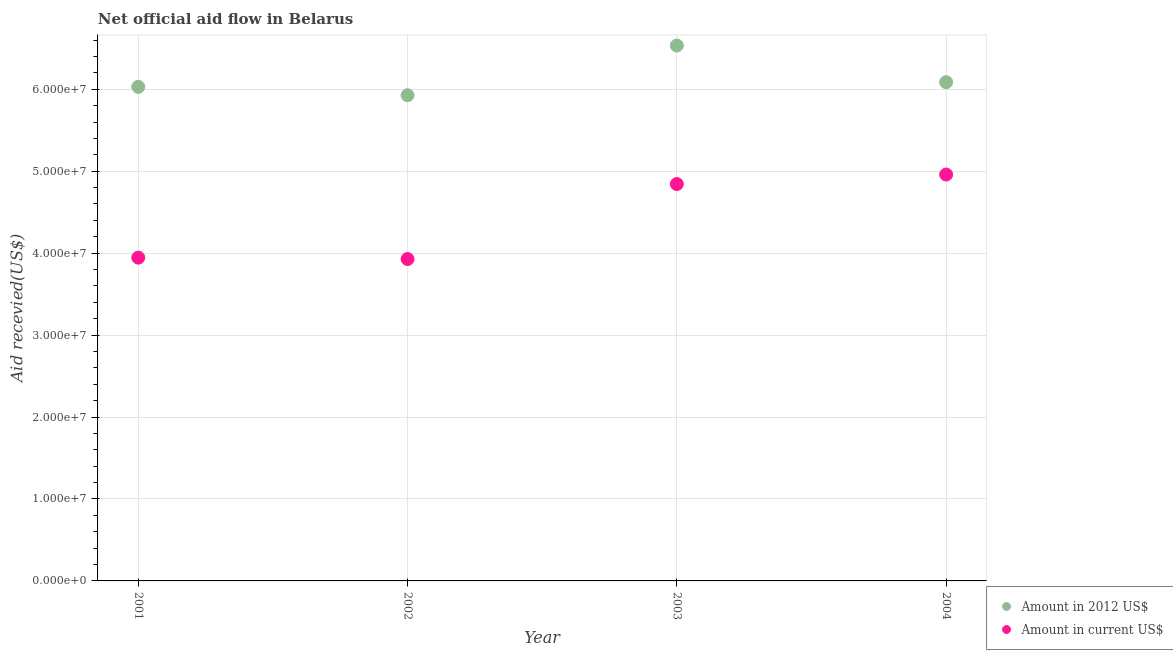Is the number of dotlines equal to the number of legend labels?
Offer a terse response. Yes. What is the amount of aid received(expressed in 2012 us$) in 2001?
Provide a succinct answer. 6.03e+07. Across all years, what is the maximum amount of aid received(expressed in us$)?
Make the answer very short. 4.96e+07. Across all years, what is the minimum amount of aid received(expressed in 2012 us$)?
Keep it short and to the point. 5.93e+07. In which year was the amount of aid received(expressed in 2012 us$) minimum?
Ensure brevity in your answer.  2002. What is the total amount of aid received(expressed in 2012 us$) in the graph?
Make the answer very short. 2.46e+08. What is the difference between the amount of aid received(expressed in 2012 us$) in 2001 and that in 2004?
Ensure brevity in your answer.  -5.70e+05. What is the difference between the amount of aid received(expressed in 2012 us$) in 2003 and the amount of aid received(expressed in us$) in 2004?
Keep it short and to the point. 1.57e+07. What is the average amount of aid received(expressed in us$) per year?
Your response must be concise. 4.42e+07. In the year 2001, what is the difference between the amount of aid received(expressed in us$) and amount of aid received(expressed in 2012 us$)?
Offer a terse response. -2.08e+07. What is the ratio of the amount of aid received(expressed in us$) in 2001 to that in 2002?
Offer a very short reply. 1. What is the difference between the highest and the second highest amount of aid received(expressed in us$)?
Give a very brief answer. 1.16e+06. What is the difference between the highest and the lowest amount of aid received(expressed in 2012 us$)?
Ensure brevity in your answer.  6.06e+06. In how many years, is the amount of aid received(expressed in us$) greater than the average amount of aid received(expressed in us$) taken over all years?
Offer a terse response. 2. Does the amount of aid received(expressed in us$) monotonically increase over the years?
Ensure brevity in your answer.  No. Is the amount of aid received(expressed in us$) strictly greater than the amount of aid received(expressed in 2012 us$) over the years?
Provide a short and direct response. No. Is the amount of aid received(expressed in 2012 us$) strictly less than the amount of aid received(expressed in us$) over the years?
Your answer should be very brief. No. How many years are there in the graph?
Offer a very short reply. 4. What is the difference between two consecutive major ticks on the Y-axis?
Offer a terse response. 1.00e+07. Are the values on the major ticks of Y-axis written in scientific E-notation?
Give a very brief answer. Yes. What is the title of the graph?
Your answer should be compact. Net official aid flow in Belarus. What is the label or title of the Y-axis?
Make the answer very short. Aid recevied(US$). What is the Aid recevied(US$) in Amount in 2012 US$ in 2001?
Provide a succinct answer. 6.03e+07. What is the Aid recevied(US$) in Amount in current US$ in 2001?
Provide a short and direct response. 3.94e+07. What is the Aid recevied(US$) in Amount in 2012 US$ in 2002?
Keep it short and to the point. 5.93e+07. What is the Aid recevied(US$) of Amount in current US$ in 2002?
Offer a very short reply. 3.93e+07. What is the Aid recevied(US$) in Amount in 2012 US$ in 2003?
Offer a very short reply. 6.53e+07. What is the Aid recevied(US$) in Amount in current US$ in 2003?
Offer a terse response. 4.84e+07. What is the Aid recevied(US$) of Amount in 2012 US$ in 2004?
Make the answer very short. 6.09e+07. What is the Aid recevied(US$) in Amount in current US$ in 2004?
Offer a very short reply. 4.96e+07. Across all years, what is the maximum Aid recevied(US$) in Amount in 2012 US$?
Provide a short and direct response. 6.53e+07. Across all years, what is the maximum Aid recevied(US$) of Amount in current US$?
Your answer should be compact. 4.96e+07. Across all years, what is the minimum Aid recevied(US$) in Amount in 2012 US$?
Provide a short and direct response. 5.93e+07. Across all years, what is the minimum Aid recevied(US$) of Amount in current US$?
Provide a short and direct response. 3.93e+07. What is the total Aid recevied(US$) of Amount in 2012 US$ in the graph?
Offer a very short reply. 2.46e+08. What is the total Aid recevied(US$) in Amount in current US$ in the graph?
Provide a succinct answer. 1.77e+08. What is the difference between the Aid recevied(US$) of Amount in 2012 US$ in 2001 and that in 2002?
Offer a terse response. 1.02e+06. What is the difference between the Aid recevied(US$) in Amount in current US$ in 2001 and that in 2002?
Ensure brevity in your answer.  1.70e+05. What is the difference between the Aid recevied(US$) of Amount in 2012 US$ in 2001 and that in 2003?
Ensure brevity in your answer.  -5.04e+06. What is the difference between the Aid recevied(US$) of Amount in current US$ in 2001 and that in 2003?
Keep it short and to the point. -8.98e+06. What is the difference between the Aid recevied(US$) in Amount in 2012 US$ in 2001 and that in 2004?
Your answer should be compact. -5.70e+05. What is the difference between the Aid recevied(US$) of Amount in current US$ in 2001 and that in 2004?
Give a very brief answer. -1.01e+07. What is the difference between the Aid recevied(US$) in Amount in 2012 US$ in 2002 and that in 2003?
Give a very brief answer. -6.06e+06. What is the difference between the Aid recevied(US$) in Amount in current US$ in 2002 and that in 2003?
Your response must be concise. -9.15e+06. What is the difference between the Aid recevied(US$) of Amount in 2012 US$ in 2002 and that in 2004?
Offer a very short reply. -1.59e+06. What is the difference between the Aid recevied(US$) in Amount in current US$ in 2002 and that in 2004?
Your answer should be compact. -1.03e+07. What is the difference between the Aid recevied(US$) in Amount in 2012 US$ in 2003 and that in 2004?
Offer a terse response. 4.47e+06. What is the difference between the Aid recevied(US$) in Amount in current US$ in 2003 and that in 2004?
Make the answer very short. -1.16e+06. What is the difference between the Aid recevied(US$) in Amount in 2012 US$ in 2001 and the Aid recevied(US$) in Amount in current US$ in 2002?
Your answer should be compact. 2.10e+07. What is the difference between the Aid recevied(US$) of Amount in 2012 US$ in 2001 and the Aid recevied(US$) of Amount in current US$ in 2003?
Give a very brief answer. 1.19e+07. What is the difference between the Aid recevied(US$) in Amount in 2012 US$ in 2001 and the Aid recevied(US$) in Amount in current US$ in 2004?
Provide a succinct answer. 1.07e+07. What is the difference between the Aid recevied(US$) of Amount in 2012 US$ in 2002 and the Aid recevied(US$) of Amount in current US$ in 2003?
Make the answer very short. 1.08e+07. What is the difference between the Aid recevied(US$) in Amount in 2012 US$ in 2002 and the Aid recevied(US$) in Amount in current US$ in 2004?
Offer a terse response. 9.68e+06. What is the difference between the Aid recevied(US$) of Amount in 2012 US$ in 2003 and the Aid recevied(US$) of Amount in current US$ in 2004?
Ensure brevity in your answer.  1.57e+07. What is the average Aid recevied(US$) in Amount in 2012 US$ per year?
Make the answer very short. 6.14e+07. What is the average Aid recevied(US$) of Amount in current US$ per year?
Your answer should be compact. 4.42e+07. In the year 2001, what is the difference between the Aid recevied(US$) in Amount in 2012 US$ and Aid recevied(US$) in Amount in current US$?
Give a very brief answer. 2.08e+07. In the year 2002, what is the difference between the Aid recevied(US$) of Amount in 2012 US$ and Aid recevied(US$) of Amount in current US$?
Offer a very short reply. 2.00e+07. In the year 2003, what is the difference between the Aid recevied(US$) in Amount in 2012 US$ and Aid recevied(US$) in Amount in current US$?
Ensure brevity in your answer.  1.69e+07. In the year 2004, what is the difference between the Aid recevied(US$) in Amount in 2012 US$ and Aid recevied(US$) in Amount in current US$?
Your answer should be very brief. 1.13e+07. What is the ratio of the Aid recevied(US$) in Amount in 2012 US$ in 2001 to that in 2002?
Make the answer very short. 1.02. What is the ratio of the Aid recevied(US$) in Amount in current US$ in 2001 to that in 2002?
Offer a very short reply. 1. What is the ratio of the Aid recevied(US$) of Amount in 2012 US$ in 2001 to that in 2003?
Your answer should be compact. 0.92. What is the ratio of the Aid recevied(US$) in Amount in current US$ in 2001 to that in 2003?
Give a very brief answer. 0.81. What is the ratio of the Aid recevied(US$) of Amount in 2012 US$ in 2001 to that in 2004?
Offer a very short reply. 0.99. What is the ratio of the Aid recevied(US$) in Amount in current US$ in 2001 to that in 2004?
Provide a short and direct response. 0.8. What is the ratio of the Aid recevied(US$) of Amount in 2012 US$ in 2002 to that in 2003?
Ensure brevity in your answer.  0.91. What is the ratio of the Aid recevied(US$) of Amount in current US$ in 2002 to that in 2003?
Your answer should be very brief. 0.81. What is the ratio of the Aid recevied(US$) in Amount in 2012 US$ in 2002 to that in 2004?
Make the answer very short. 0.97. What is the ratio of the Aid recevied(US$) in Amount in current US$ in 2002 to that in 2004?
Provide a succinct answer. 0.79. What is the ratio of the Aid recevied(US$) of Amount in 2012 US$ in 2003 to that in 2004?
Your response must be concise. 1.07. What is the ratio of the Aid recevied(US$) of Amount in current US$ in 2003 to that in 2004?
Your answer should be very brief. 0.98. What is the difference between the highest and the second highest Aid recevied(US$) of Amount in 2012 US$?
Offer a very short reply. 4.47e+06. What is the difference between the highest and the second highest Aid recevied(US$) of Amount in current US$?
Offer a very short reply. 1.16e+06. What is the difference between the highest and the lowest Aid recevied(US$) of Amount in 2012 US$?
Your response must be concise. 6.06e+06. What is the difference between the highest and the lowest Aid recevied(US$) in Amount in current US$?
Your answer should be very brief. 1.03e+07. 